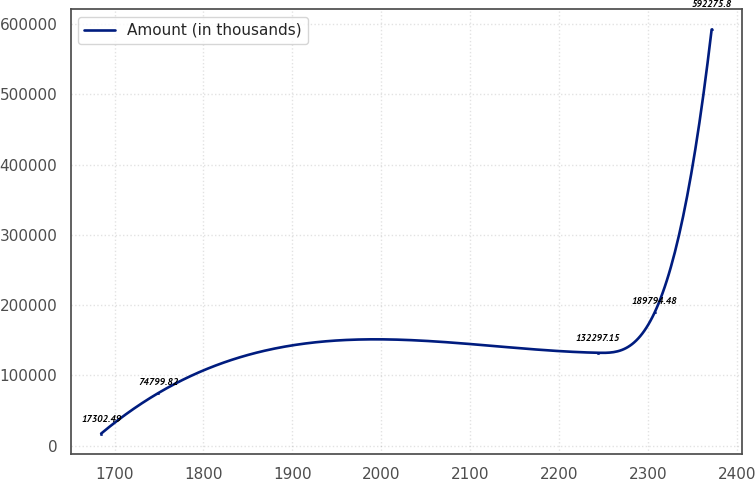Convert chart to OTSL. <chart><loc_0><loc_0><loc_500><loc_500><line_chart><ecel><fcel>Amount (in thousands)<nl><fcel>1684.96<fcel>17302.5<nl><fcel>1748.97<fcel>74799.8<nl><fcel>2243.1<fcel>132297<nl><fcel>2307.11<fcel>189794<nl><fcel>2371.12<fcel>592276<nl></chart> 